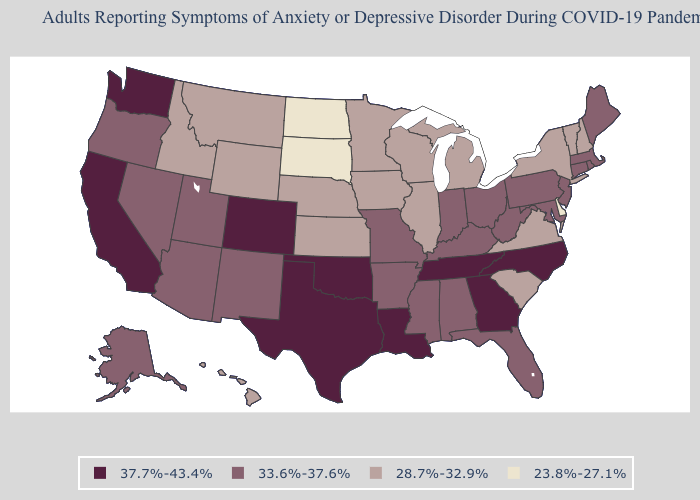Name the states that have a value in the range 37.7%-43.4%?
Be succinct. California, Colorado, Georgia, Louisiana, North Carolina, Oklahoma, Tennessee, Texas, Washington. Does Nebraska have the lowest value in the MidWest?
Keep it brief. No. Name the states that have a value in the range 23.8%-27.1%?
Short answer required. Delaware, North Dakota, South Dakota. What is the value of New Jersey?
Be succinct. 33.6%-37.6%. Among the states that border West Virginia , does Virginia have the highest value?
Give a very brief answer. No. Name the states that have a value in the range 33.6%-37.6%?
Short answer required. Alabama, Alaska, Arizona, Arkansas, Connecticut, Florida, Indiana, Kentucky, Maine, Maryland, Massachusetts, Mississippi, Missouri, Nevada, New Jersey, New Mexico, Ohio, Oregon, Pennsylvania, Rhode Island, Utah, West Virginia. What is the value of New Hampshire?
Be succinct. 28.7%-32.9%. Which states have the lowest value in the USA?
Keep it brief. Delaware, North Dakota, South Dakota. Does Illinois have a higher value than North Dakota?
Give a very brief answer. Yes. What is the highest value in states that border Rhode Island?
Write a very short answer. 33.6%-37.6%. Does West Virginia have the highest value in the USA?
Short answer required. No. Name the states that have a value in the range 23.8%-27.1%?
Concise answer only. Delaware, North Dakota, South Dakota. What is the highest value in states that border Alabama?
Concise answer only. 37.7%-43.4%. Does the map have missing data?
Answer briefly. No. Does Oklahoma have the highest value in the USA?
Short answer required. Yes. 